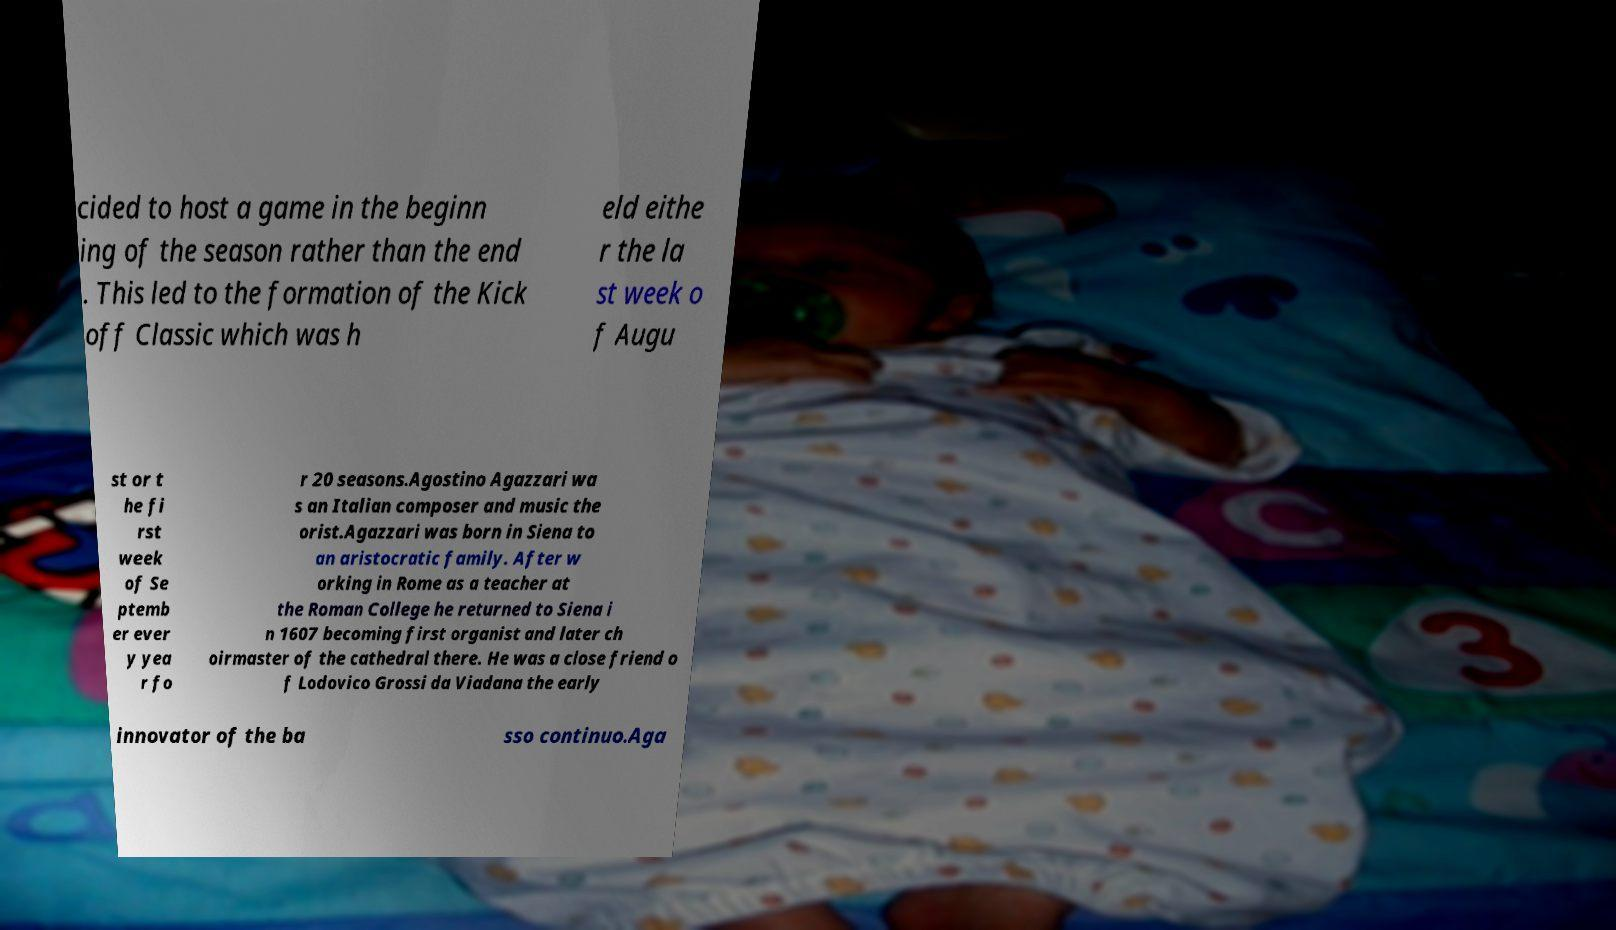Could you extract and type out the text from this image? cided to host a game in the beginn ing of the season rather than the end . This led to the formation of the Kick off Classic which was h eld eithe r the la st week o f Augu st or t he fi rst week of Se ptemb er ever y yea r fo r 20 seasons.Agostino Agazzari wa s an Italian composer and music the orist.Agazzari was born in Siena to an aristocratic family. After w orking in Rome as a teacher at the Roman College he returned to Siena i n 1607 becoming first organist and later ch oirmaster of the cathedral there. He was a close friend o f Lodovico Grossi da Viadana the early innovator of the ba sso continuo.Aga 